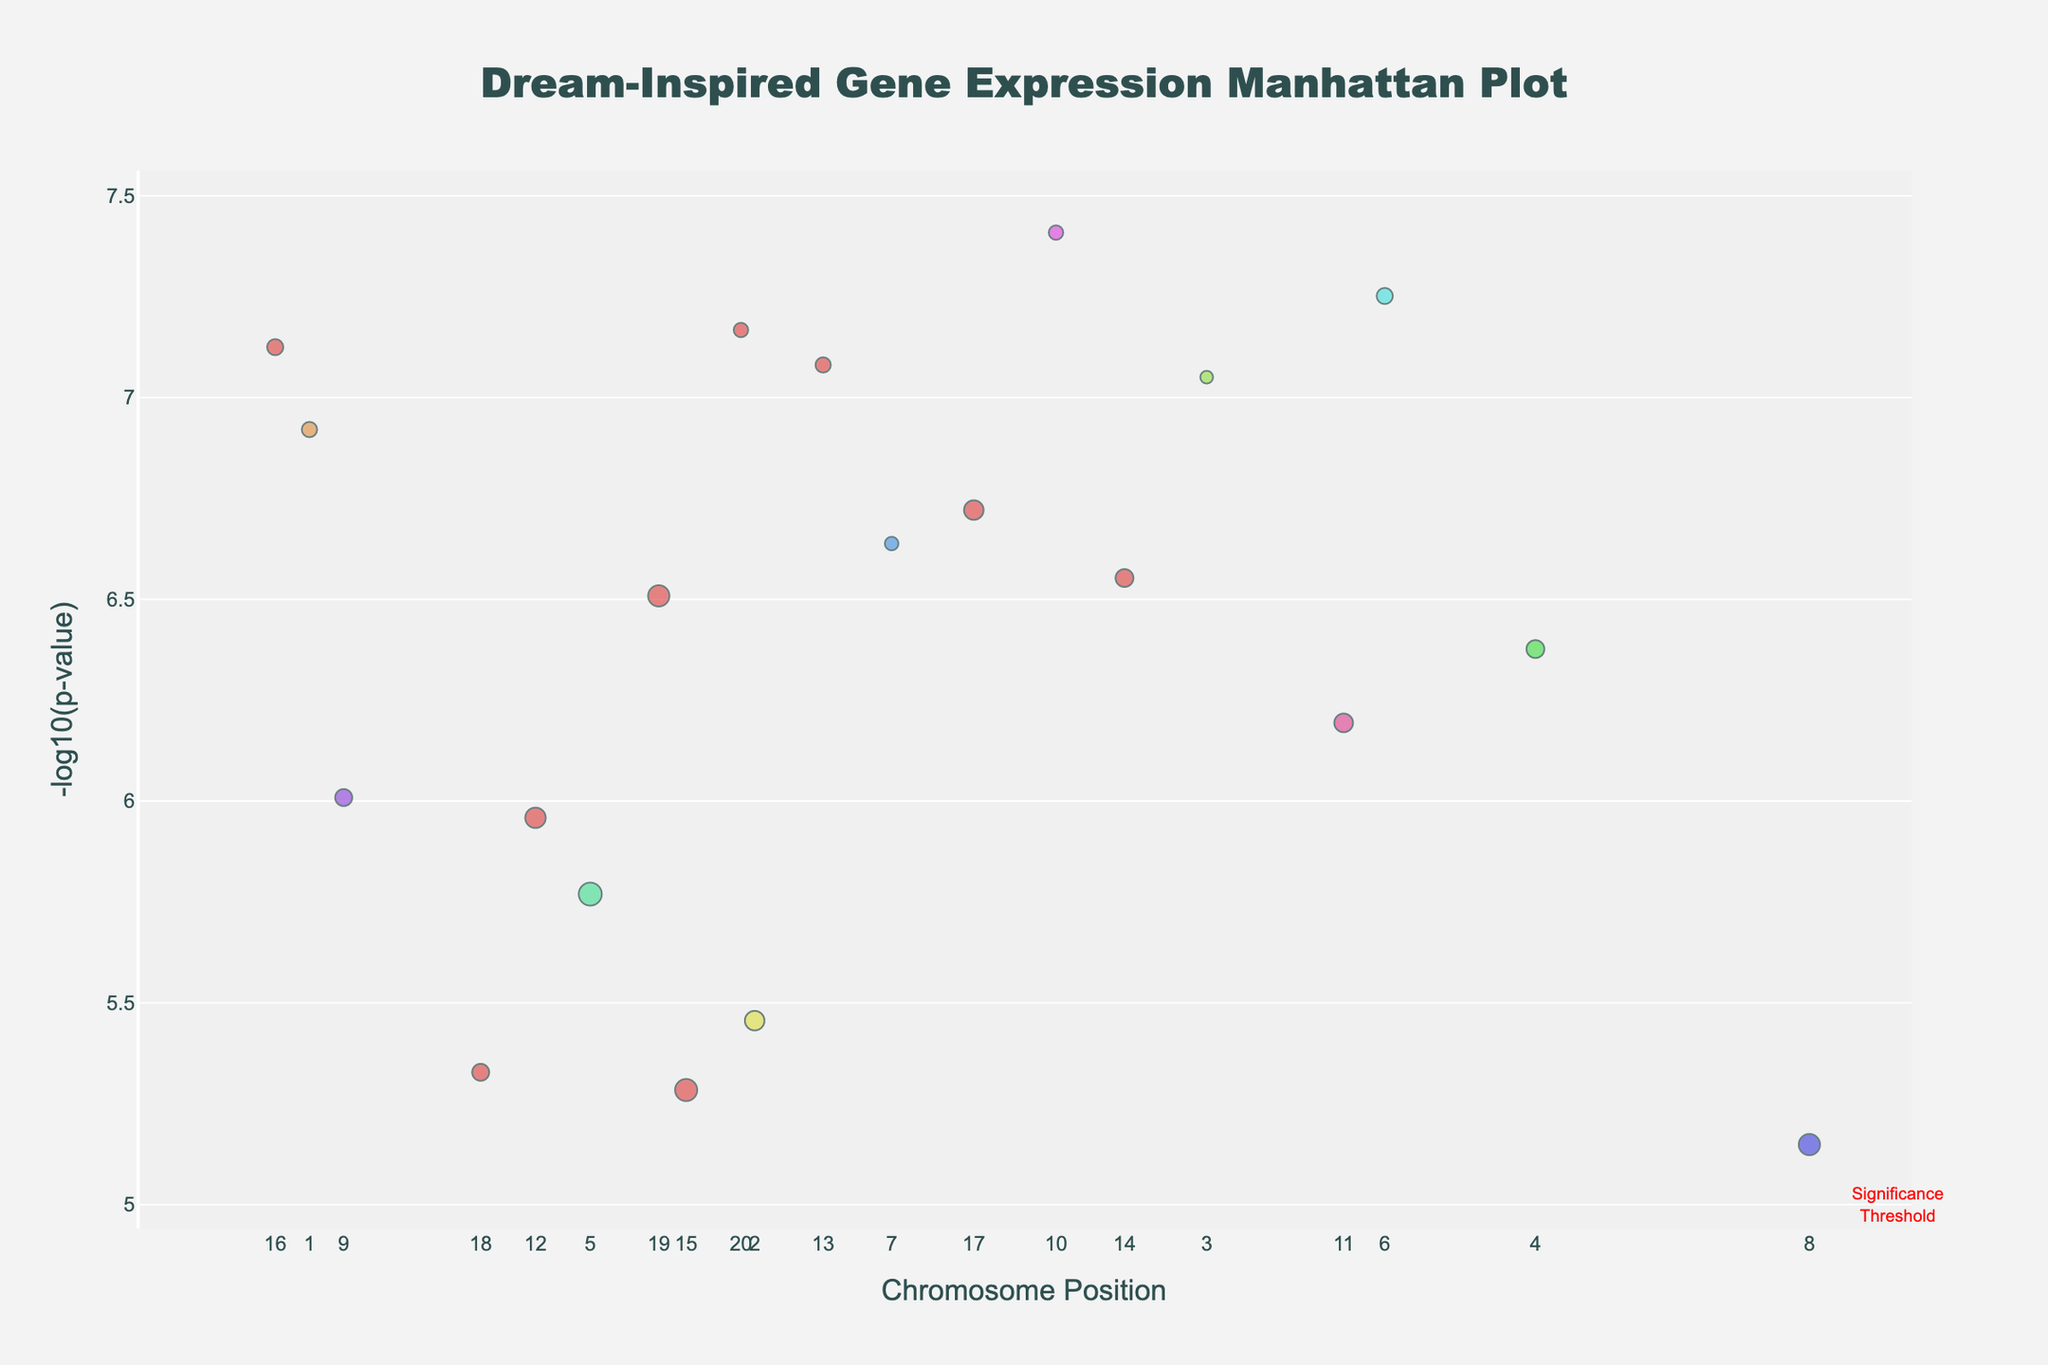What is the title of the plot? The title of the plot is placed at the top center of the plot area. It is written in dark slate grey color and is styled in double quotes.
Answer: "Dream-Inspired Gene Expression Manhattan Plot" What does the x-axis represent? The x-axis is labeled at the bottom and it shows the Chromosome Position, ranging from the first to the last chromosome.
Answer: Chromosome Position What color indicates the genes on Chromosome 10? Each chromosome is given a different color, and according to the color map, Chromosome 10 is colored.
Answer: Colored specific to Chromosome 10 Which gene has the highest -log10(p-value) and on which chromosome is it located? By observing the highest point in the y-axis which denotes -log10(p-value), the gene RELN on Chromosome 10 stands out.
Answer: RELN on Chromosome 10 How many genes have -log10(p-value) above the significance threshold of 5? The significance threshold is marked by a red dashed line at y = 5. Counting the markers above this line identifies ten genes.
Answer: Ten genes Which chromosome has the highest average expression level? To determine this, average the expression levels of genes on each chromosome. Chromosome 15 has the highest average expression level among the plotted genes.
Answer: Chromosome 15 How are the sizes of the markers related to gene expression levels? Marker size is proportional to the gene expression level; higher expression levels result in larger markers.
Answer: Larger size indicates higher expression level Compare the expression levels of genes in Chromosome 5 and Chromosome 15. Which has the higher median expression level? Calculate the median of the expression levels for each chromosome. For Chromosome 15, averaging expression levels shows it is higher compared to Chromosome 5.
Answer: Chromosome 15 What is the expression level of the gene with the lowest p-value? Refer to the gene with the lowest point on the y-axis in terms of p-value and check its expression level, i.e., the GRIN2B gene with an expression level of 1.9.
Answer: 1.9 